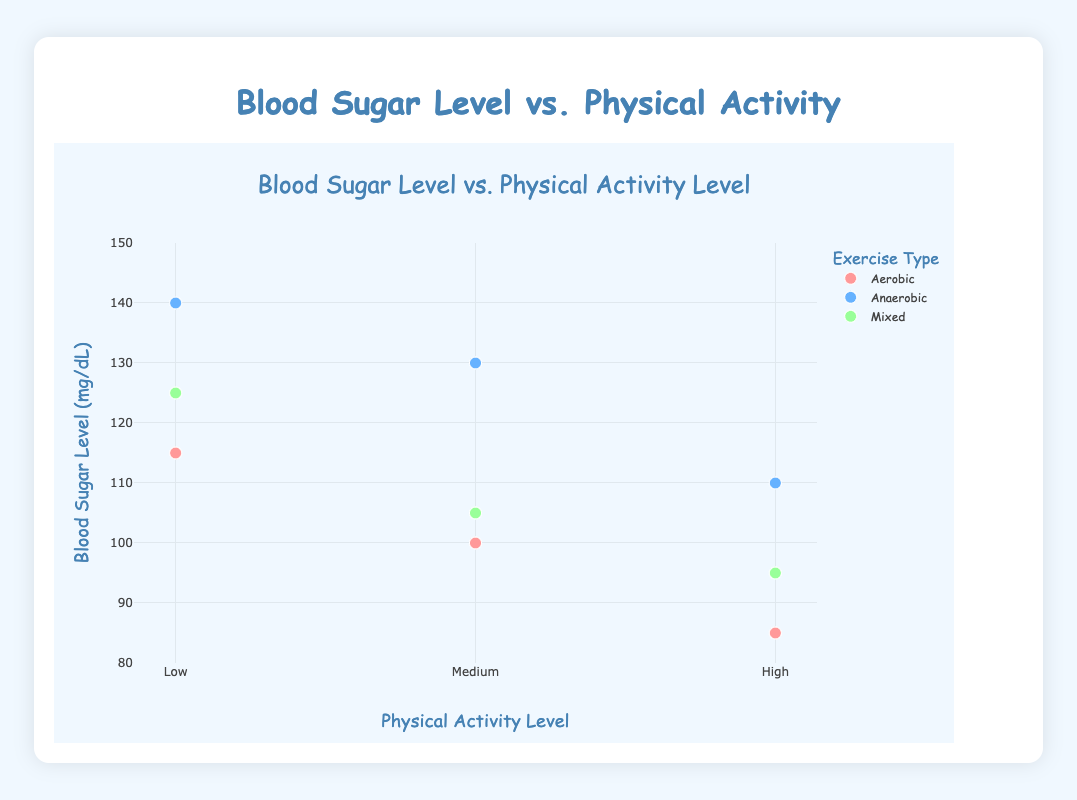what is the title of the plot? The title of the plot is displayed prominently at the top center of the figure. By reading the title, we can understand that the plot is about the relationship between Blood Sugar Level and Physical Activity Level.
Answer: Blood Sugar Level vs. Physical Activity Level What are the exercise types compared in the plot? The legend on the right side of the plot indicates the different exercise types compared. There are three exercise types distinguished by different colors in the legend.
Answer: Aerobic, Anaerobic, Mixed What is the average blood sugar level for aerobic exercise? For aerobic exercise, we need to find the average of blood sugar levels corresponding to low, medium, and high physical activity levels. These values are 115, 100, and 85. Summing these values: 115 + 100 + 85 = 300. Now, divide by the number of data points, which is 3, 300 / 3 = 100.
Answer: 100 Which exercise type shows the lowest blood sugar level at high physical activity? We need to compare the blood sugar levels at high physical activity for each exercise type. Aerobic has 85, Anaerobic has 110, and Mixed has 95. The lowest value among these is 85.
Answer: Aerobic is there a difference in Blood Sugar Levels for Mixed exercise between medium and high physical activity? For Mixed exercise, the blood sugar levels at medium and high physical activity are 105 and 95, respectively. The difference is calculated by subtracting 95 from 105: 105 - 95 = 10.
Answer: 10 For which physical activity level (Low, Medium, High) do we observe the highest blood sugar level, and which exercise type does it correspond to? Scan the plot to determine the highest blood sugar level. It is at low physical activity level for Anaerobic exercise with a value of 140.
Answer: Low, Anaerobic What is the total number of data points plotted? Counting each individual point plotted in the scatter plot for all exercise types and physical activity levels, we have 9 points: 3 for Aerobic, 3 for Anaerobic, and 3 for Mixed.
Answer: 9 